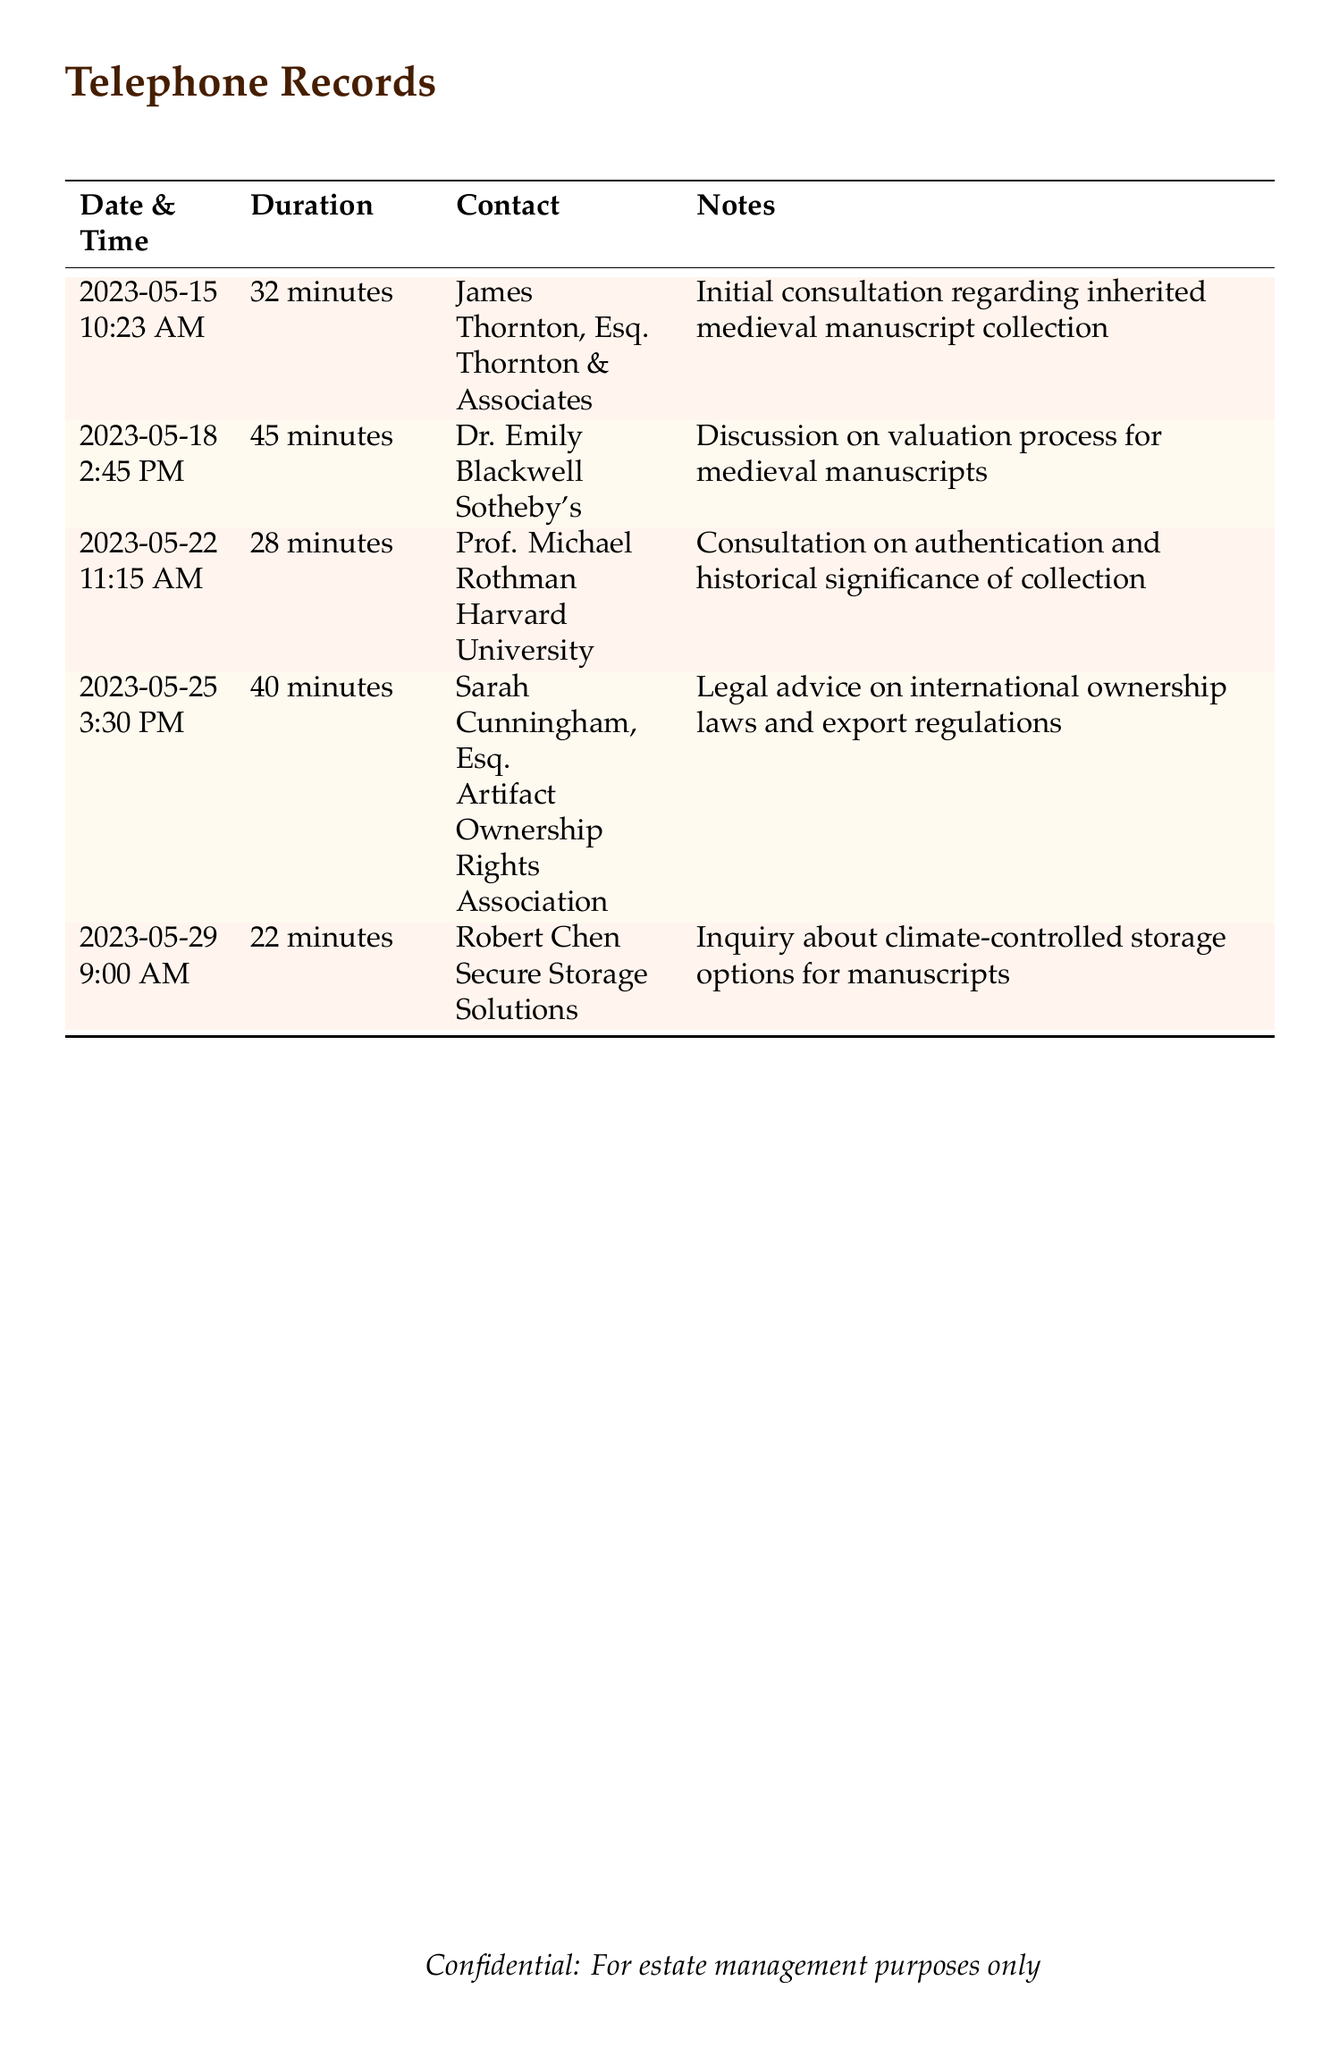What date did the consultation with James Thornton occur? The date of the consultation is listed in the document, specifically noting that it was on May 15, 2023.
Answer: May 15, 2023 How long was the consultation with Dr. Emily Blackwell? The duration of the call with Dr. Emily Blackwell is explicitly stated in the document as 45 minutes.
Answer: 45 minutes Who provided legal advice on international ownership laws? The person who provided this legal advice is indicated in the document as Sarah Cunningham, Esq.
Answer: Sarah Cunningham, Esq What was discussed during the consultation on May 22? The notes for the consultation on May 22 indicate a discussion about authentication and historical significance.
Answer: Authentication and historical significance How many total consultations are listed in the document? The total number of consultations can be determined by counting the entries in the table, which totals five.
Answer: Five What is the name of the contact associated with artifact ownership rights? The contact associated with artifact ownership rights is listed as Sarah Cunningham, Esq.
Answer: Sarah Cunningham, Esq What type of storage inquiry was made on May 29? The inquiry made on May 29 was specifically about climate-controlled storage options for manuscripts.
Answer: Climate-controlled storage options What is the purpose of the document according to the footer? The footer indicates that the document is intended for a specific purpose related to estate management.
Answer: Estate management purposes only 